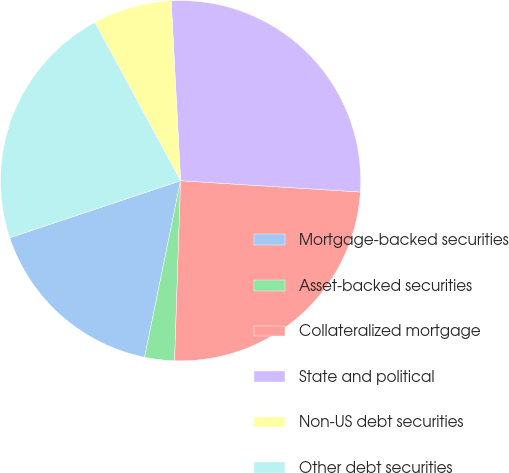<chart> <loc_0><loc_0><loc_500><loc_500><pie_chart><fcel>Mortgage-backed securities<fcel>Asset-backed securities<fcel>Collateralized mortgage<fcel>State and political<fcel>Non-US debt securities<fcel>Other debt securities<nl><fcel>16.67%<fcel>2.67%<fcel>24.53%<fcel>26.83%<fcel>7.06%<fcel>22.23%<nl></chart> 